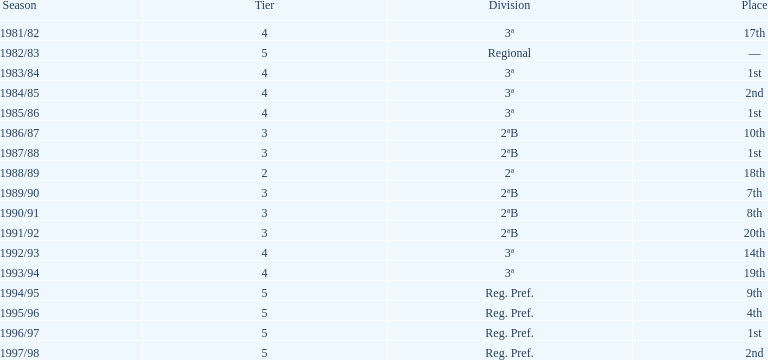What was the duration of their stay in tier 3 in years? 5. 